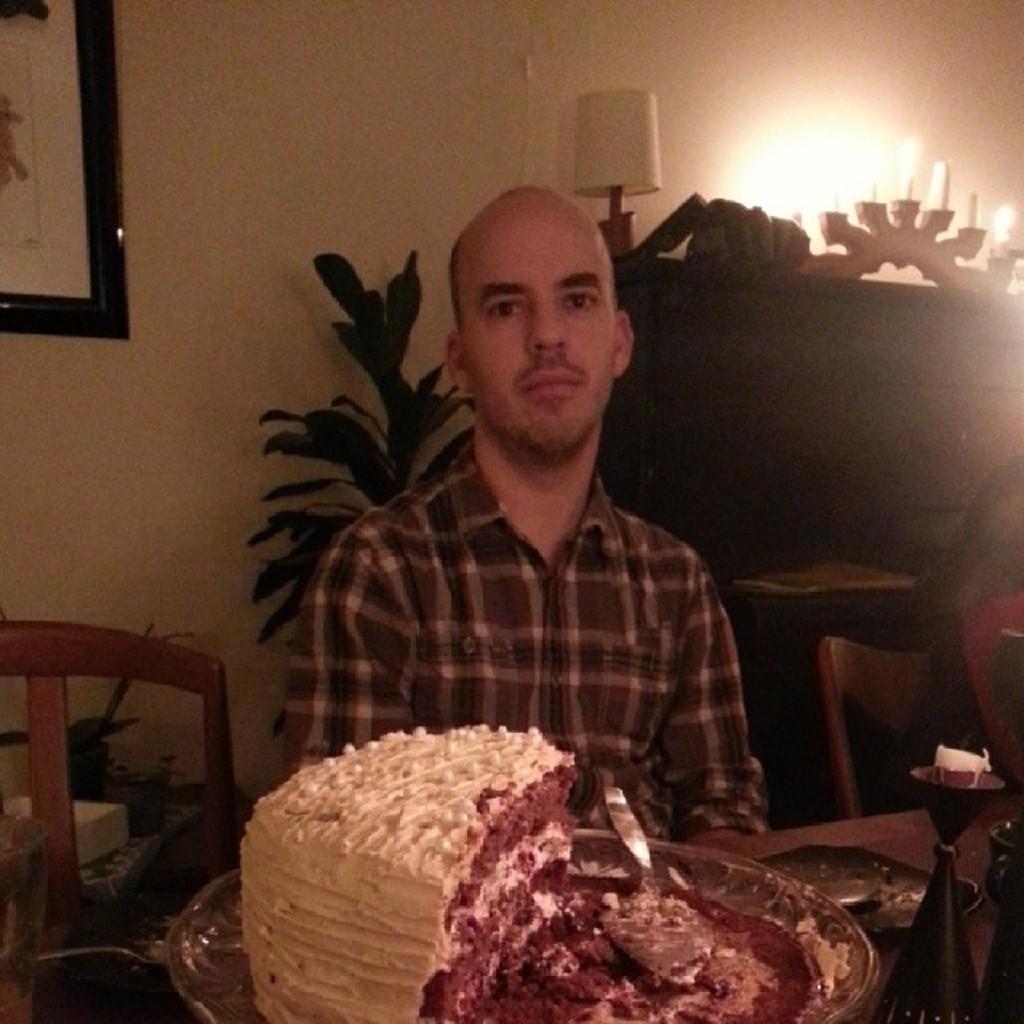In one or two sentences, can you explain what this image depicts? In the picture we can see a man sitting near the table on it, we can see a cake and in the background, we can see a house plant and a wall with some photo frame to it. 